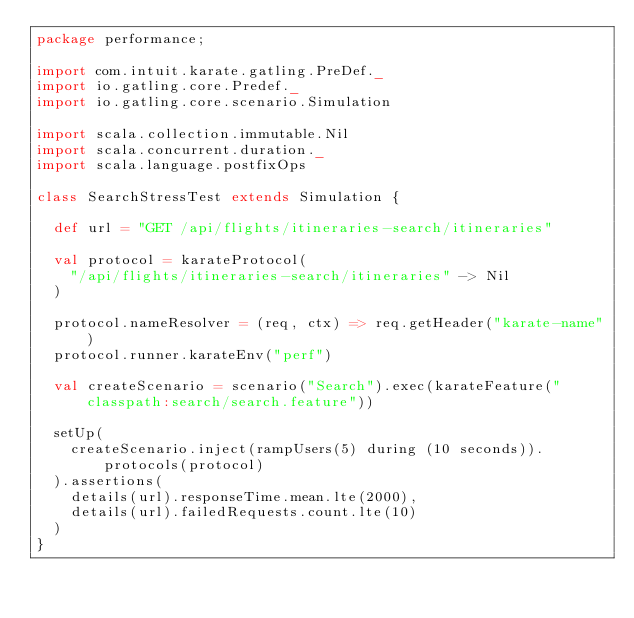<code> <loc_0><loc_0><loc_500><loc_500><_Scala_>package performance;

import com.intuit.karate.gatling.PreDef._
import io.gatling.core.Predef._
import io.gatling.core.scenario.Simulation

import scala.collection.immutable.Nil
import scala.concurrent.duration._
import scala.language.postfixOps

class SearchStressTest extends Simulation {

  def url = "GET /api/flights/itineraries-search/itineraries"

  val protocol = karateProtocol(
    "/api/flights/itineraries-search/itineraries" -> Nil
  )

  protocol.nameResolver = (req, ctx) => req.getHeader("karate-name")
  protocol.runner.karateEnv("perf")

  val createScenario = scenario("Search").exec(karateFeature("classpath:search/search.feature"))

  setUp(
    createScenario.inject(rampUsers(5) during (10 seconds)).protocols(protocol)
  ).assertions(
    details(url).responseTime.mean.lte(2000),
    details(url).failedRequests.count.lte(10)
  )
}

</code> 